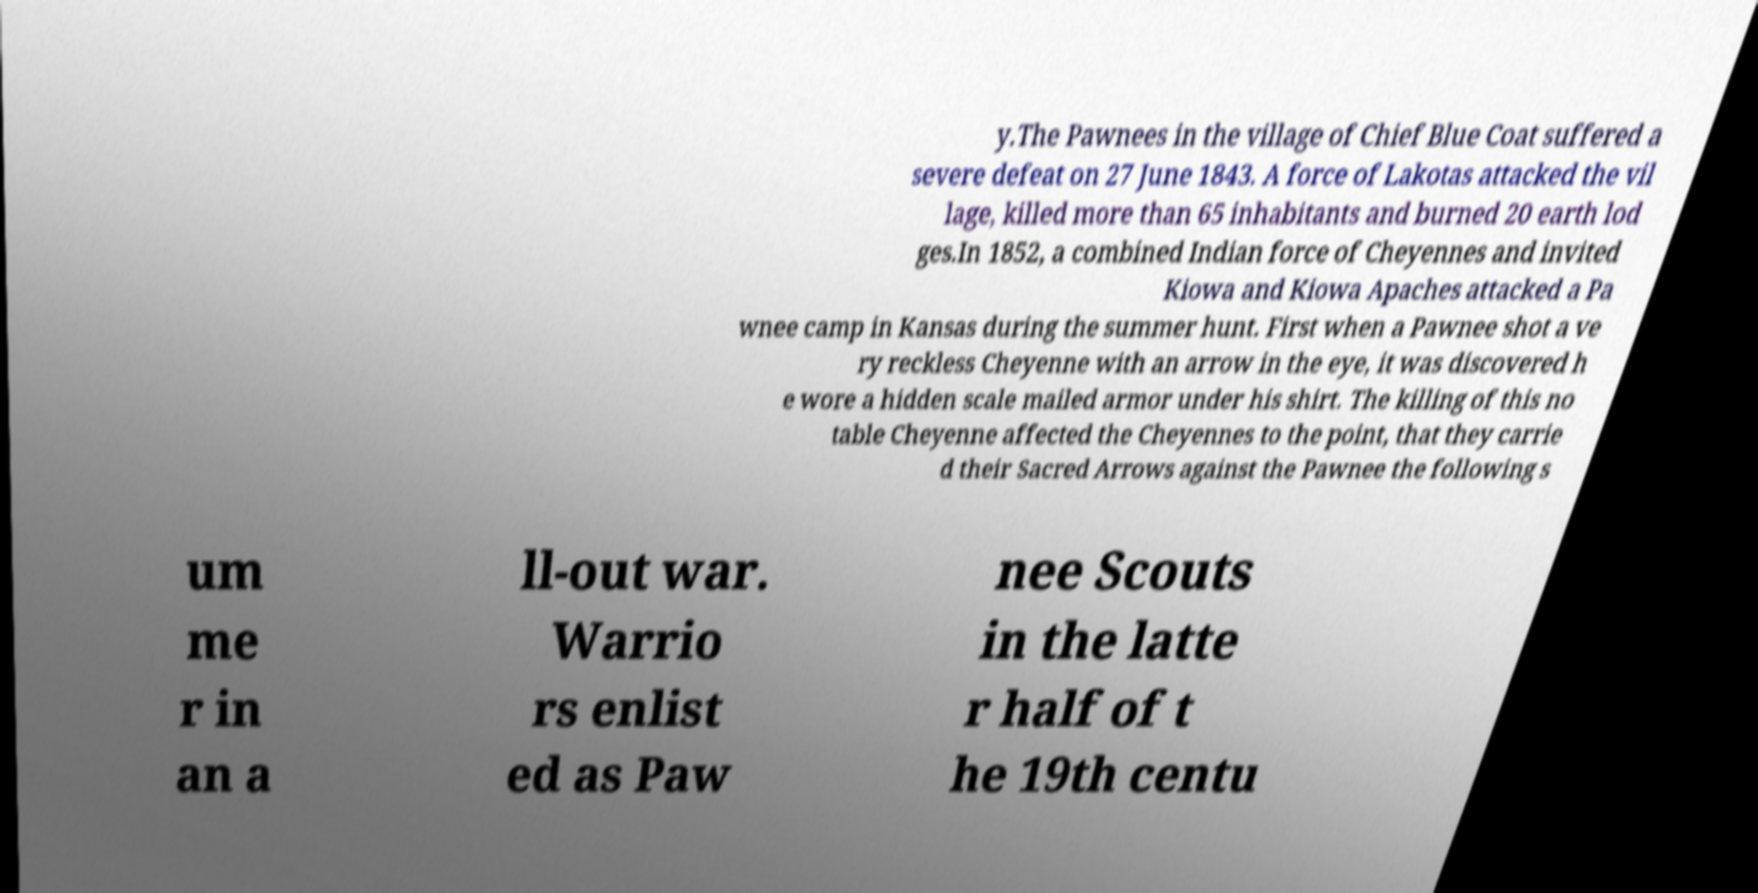There's text embedded in this image that I need extracted. Can you transcribe it verbatim? y.The Pawnees in the village of Chief Blue Coat suffered a severe defeat on 27 June 1843. A force of Lakotas attacked the vil lage, killed more than 65 inhabitants and burned 20 earth lod ges.In 1852, a combined Indian force of Cheyennes and invited Kiowa and Kiowa Apaches attacked a Pa wnee camp in Kansas during the summer hunt. First when a Pawnee shot a ve ry reckless Cheyenne with an arrow in the eye, it was discovered h e wore a hidden scale mailed armor under his shirt. The killing of this no table Cheyenne affected the Cheyennes to the point, that they carrie d their Sacred Arrows against the Pawnee the following s um me r in an a ll-out war. Warrio rs enlist ed as Paw nee Scouts in the latte r half of t he 19th centu 